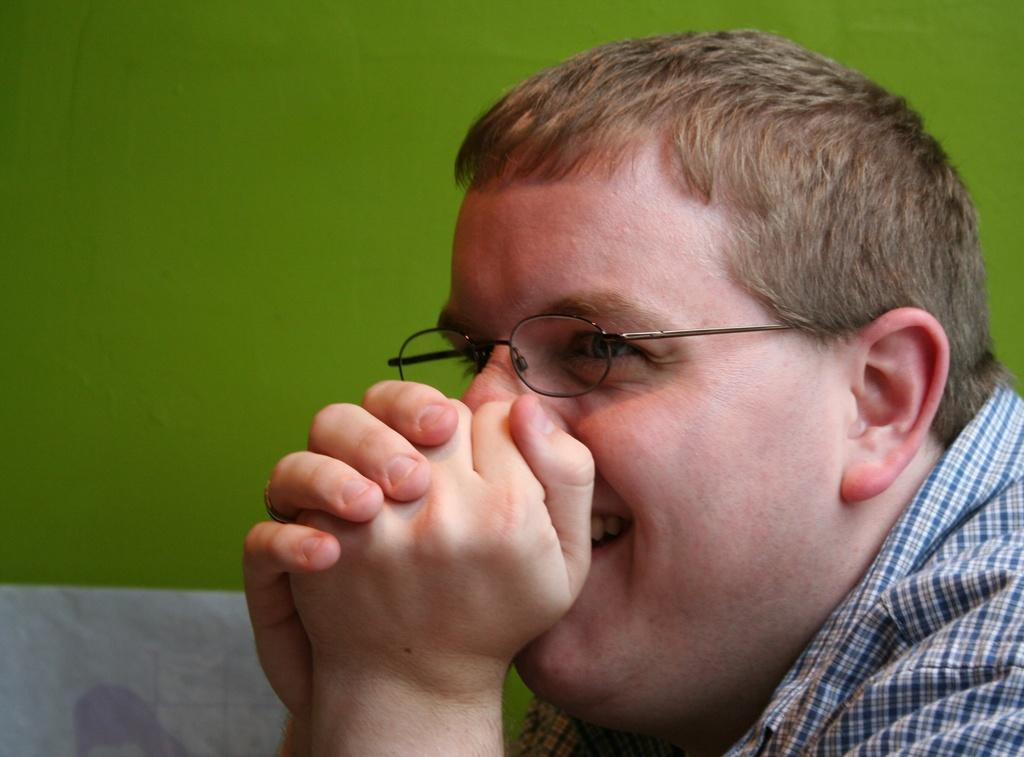What is the main subject in the foreground of the image? There is a man in the foreground of the image. What can be seen in the background of the image? There is a wall in the background of the image. What type of canvas is the man painting in the image? There is no canvas present in the image, and the man is not depicted as painting. 